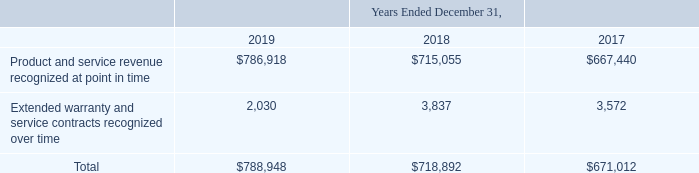ADVANCED ENERGY INDUSTRIES, INC. NOTES TO CONSOLIDATED FINANCIAL STATEMENTS – (continued) (in thousands, except per share amounts) ADVANCED ENERGY INDUSTRIES, INC. NOTES TO CONSOLIDATED FINANCIAL STATEMENTS – (continued) (in thousands, except per share amounts)
The following table presents our net sales by extended warranty and service contracts recognized over time and our product and service revenue recognized at a point in time:
What was the Product and service revenue recognized at point in time in 2019?
Answer scale should be: thousand. $786,918. What was the Extended warranty and service contracts recognized over time in 2018?
Answer scale should be: thousand. 3,837. What does the table represent? Net sales by extended warranty and service contracts recognized over time and our product and service revenue recognized at a point in time. What was the change in Product and service revenue recognized at point in time between 2018 and 2019?
Answer scale should be: thousand. $786,918-$715,055
Answer: 71863. What was the change in Extended warranty and service contracts recognized over time between 2017 and 2018?
Answer scale should be: thousand. 3,837-3,572
Answer: 265. What was the percentage change in total net sales between 2018 and 2019?
Answer scale should be: percent. ($788,948-$718,892)/$718,892
Answer: 9.74. 